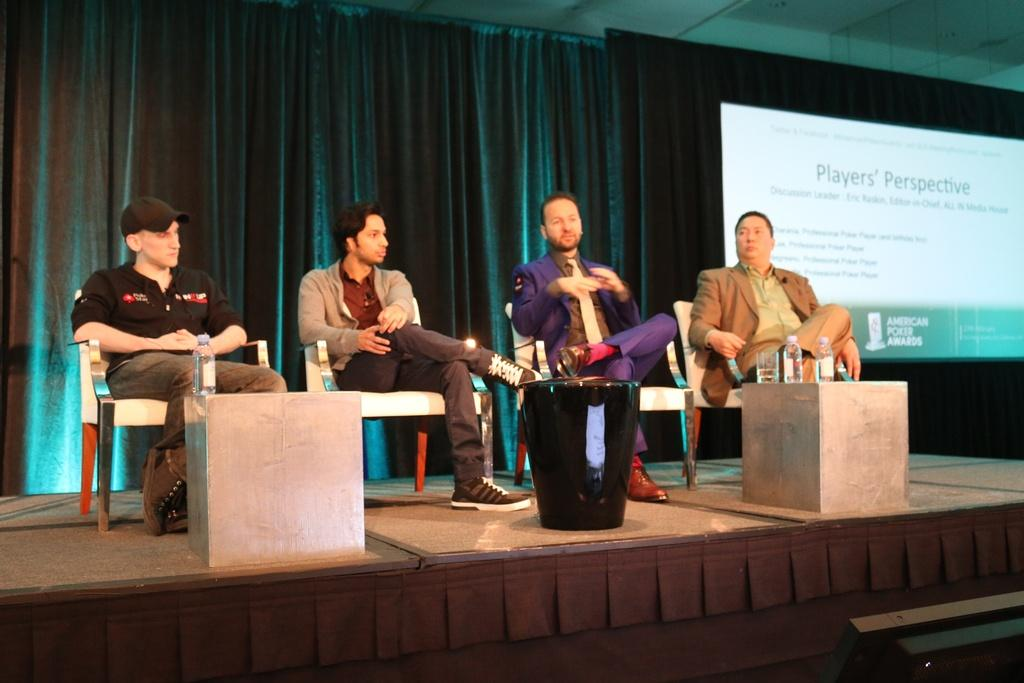How many people are sitting in the image? There are four people sitting on chairs in the image. Can you describe the appearance of one of the people? One person on the left side is wearing a cap. What can be seen on the right side of the image? There is a screen on the right side of the image. Can you tell me how many robins are sitting on the chairs in the image? There are no robins present in the image; it features four people sitting on chairs. What type of patch is visible on the screen in the image? There is no patch visible on the screen in the image; only the screen itself is mentioned. 